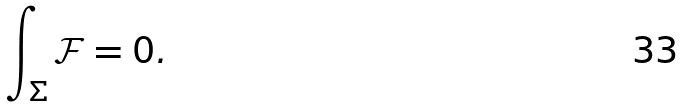<formula> <loc_0><loc_0><loc_500><loc_500>\int _ { \Sigma } \mathcal { F } = 0 .</formula> 